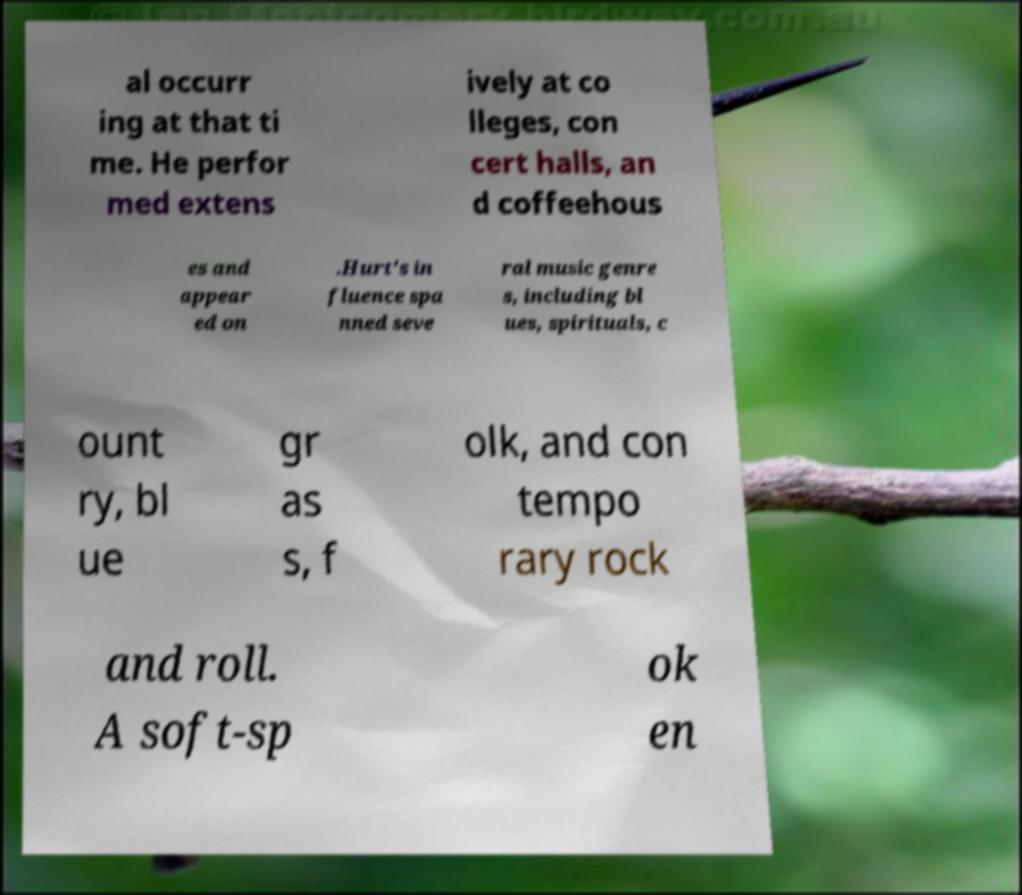Can you read and provide the text displayed in the image?This photo seems to have some interesting text. Can you extract and type it out for me? al occurr ing at that ti me. He perfor med extens ively at co lleges, con cert halls, an d coffeehous es and appear ed on .Hurt's in fluence spa nned seve ral music genre s, including bl ues, spirituals, c ount ry, bl ue gr as s, f olk, and con tempo rary rock and roll. A soft-sp ok en 